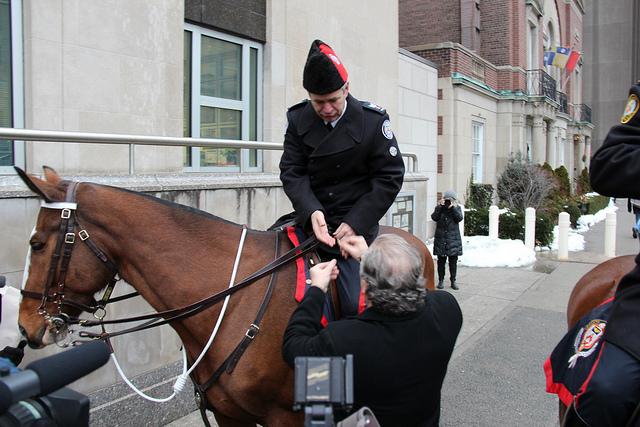Are the men passing something between them?
Be succinct. Yes. What is the man sitting on?
Be succinct. Horse. What colors are the uniforms?
Answer briefly. Black. What is the horse doing to the man?
Keep it brief. Nothing. What color is the horse's bridle?
Write a very short answer. Black. What is the person wearing on her head?
Be succinct. Hat. 